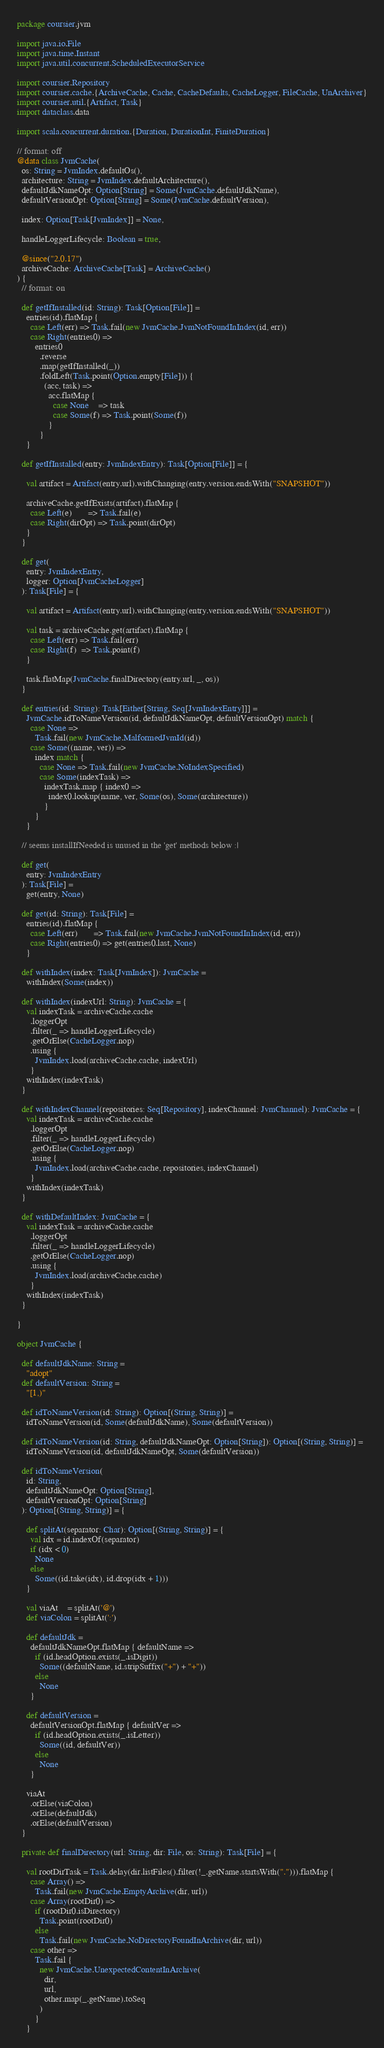Convert code to text. <code><loc_0><loc_0><loc_500><loc_500><_Scala_>package coursier.jvm

import java.io.File
import java.time.Instant
import java.util.concurrent.ScheduledExecutorService

import coursier.Repository
import coursier.cache.{ArchiveCache, Cache, CacheDefaults, CacheLogger, FileCache, UnArchiver}
import coursier.util.{Artifact, Task}
import dataclass.data

import scala.concurrent.duration.{Duration, DurationInt, FiniteDuration}

// format: off
@data class JvmCache(
  os: String = JvmIndex.defaultOs(),
  architecture: String = JvmIndex.defaultArchitecture(),
  defaultJdkNameOpt: Option[String] = Some(JvmCache.defaultJdkName),
  defaultVersionOpt: Option[String] = Some(JvmCache.defaultVersion),

  index: Option[Task[JvmIndex]] = None,

  handleLoggerLifecycle: Boolean = true,

  @since("2.0.17")
  archiveCache: ArchiveCache[Task] = ArchiveCache()
) {
  // format: on

  def getIfInstalled(id: String): Task[Option[File]] =
    entries(id).flatMap {
      case Left(err) => Task.fail(new JvmCache.JvmNotFoundInIndex(id, err))
      case Right(entries0) =>
        entries0
          .reverse
          .map(getIfInstalled(_))
          .foldLeft(Task.point(Option.empty[File])) {
            (acc, task) =>
              acc.flatMap {
                case None    => task
                case Some(f) => Task.point(Some(f))
              }
          }
    }

  def getIfInstalled(entry: JvmIndexEntry): Task[Option[File]] = {

    val artifact = Artifact(entry.url).withChanging(entry.version.endsWith("SNAPSHOT"))

    archiveCache.getIfExists(artifact).flatMap {
      case Left(e)       => Task.fail(e)
      case Right(dirOpt) => Task.point(dirOpt)
    }
  }

  def get(
    entry: JvmIndexEntry,
    logger: Option[JvmCacheLogger]
  ): Task[File] = {

    val artifact = Artifact(entry.url).withChanging(entry.version.endsWith("SNAPSHOT"))

    val task = archiveCache.get(artifact).flatMap {
      case Left(err) => Task.fail(err)
      case Right(f)  => Task.point(f)
    }

    task.flatMap(JvmCache.finalDirectory(entry.url, _, os))
  }

  def entries(id: String): Task[Either[String, Seq[JvmIndexEntry]]] =
    JvmCache.idToNameVersion(id, defaultJdkNameOpt, defaultVersionOpt) match {
      case None =>
        Task.fail(new JvmCache.MalformedJvmId(id))
      case Some((name, ver)) =>
        index match {
          case None => Task.fail(new JvmCache.NoIndexSpecified)
          case Some(indexTask) =>
            indexTask.map { index0 =>
              index0.lookup(name, ver, Some(os), Some(architecture))
            }
        }
    }

  // seems installIfNeeded is unused in the 'get' methods below :|

  def get(
    entry: JvmIndexEntry
  ): Task[File] =
    get(entry, None)

  def get(id: String): Task[File] =
    entries(id).flatMap {
      case Left(err)       => Task.fail(new JvmCache.JvmNotFoundInIndex(id, err))
      case Right(entries0) => get(entries0.last, None)
    }

  def withIndex(index: Task[JvmIndex]): JvmCache =
    withIndex(Some(index))

  def withIndex(indexUrl: String): JvmCache = {
    val indexTask = archiveCache.cache
      .loggerOpt
      .filter(_ => handleLoggerLifecycle)
      .getOrElse(CacheLogger.nop)
      .using {
        JvmIndex.load(archiveCache.cache, indexUrl)
      }
    withIndex(indexTask)
  }

  def withIndexChannel(repositories: Seq[Repository], indexChannel: JvmChannel): JvmCache = {
    val indexTask = archiveCache.cache
      .loggerOpt
      .filter(_ => handleLoggerLifecycle)
      .getOrElse(CacheLogger.nop)
      .using {
        JvmIndex.load(archiveCache.cache, repositories, indexChannel)
      }
    withIndex(indexTask)
  }

  def withDefaultIndex: JvmCache = {
    val indexTask = archiveCache.cache
      .loggerOpt
      .filter(_ => handleLoggerLifecycle)
      .getOrElse(CacheLogger.nop)
      .using {
        JvmIndex.load(archiveCache.cache)
      }
    withIndex(indexTask)
  }

}

object JvmCache {

  def defaultJdkName: String =
    "adopt"
  def defaultVersion: String =
    "[1,)"

  def idToNameVersion(id: String): Option[(String, String)] =
    idToNameVersion(id, Some(defaultJdkName), Some(defaultVersion))

  def idToNameVersion(id: String, defaultJdkNameOpt: Option[String]): Option[(String, String)] =
    idToNameVersion(id, defaultJdkNameOpt, Some(defaultVersion))

  def idToNameVersion(
    id: String,
    defaultJdkNameOpt: Option[String],
    defaultVersionOpt: Option[String]
  ): Option[(String, String)] = {

    def splitAt(separator: Char): Option[(String, String)] = {
      val idx = id.indexOf(separator)
      if (idx < 0)
        None
      else
        Some((id.take(idx), id.drop(idx + 1)))
    }

    val viaAt    = splitAt('@')
    def viaColon = splitAt(':')

    def defaultJdk =
      defaultJdkNameOpt.flatMap { defaultName =>
        if (id.headOption.exists(_.isDigit))
          Some((defaultName, id.stripSuffix("+") + "+"))
        else
          None
      }

    def defaultVersion =
      defaultVersionOpt.flatMap { defaultVer =>
        if (id.headOption.exists(_.isLetter))
          Some((id, defaultVer))
        else
          None
      }

    viaAt
      .orElse(viaColon)
      .orElse(defaultJdk)
      .orElse(defaultVersion)
  }

  private def finalDirectory(url: String, dir: File, os: String): Task[File] = {

    val rootDirTask = Task.delay(dir.listFiles().filter(!_.getName.startsWith("."))).flatMap {
      case Array() =>
        Task.fail(new JvmCache.EmptyArchive(dir, url))
      case Array(rootDir0) =>
        if (rootDir0.isDirectory)
          Task.point(rootDir0)
        else
          Task.fail(new JvmCache.NoDirectoryFoundInArchive(dir, url))
      case other =>
        Task.fail {
          new JvmCache.UnexpectedContentInArchive(
            dir,
            url,
            other.map(_.getName).toSeq
          )
        }
    }
</code> 